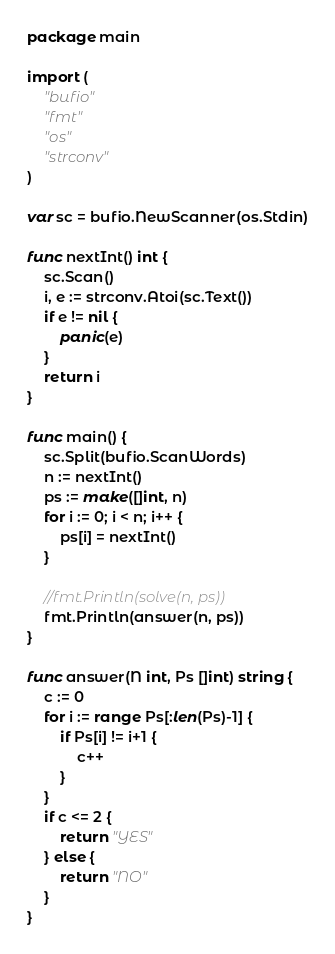<code> <loc_0><loc_0><loc_500><loc_500><_Go_>package main

import (
	"bufio"
	"fmt"
	"os"
	"strconv"
)

var sc = bufio.NewScanner(os.Stdin)

func nextInt() int {
	sc.Scan()
	i, e := strconv.Atoi(sc.Text())
	if e != nil {
		panic(e)
	}
	return i
}

func main() {
	sc.Split(bufio.ScanWords)
	n := nextInt()
	ps := make([]int, n)
	for i := 0; i < n; i++ {
		ps[i] = nextInt()
	}

	//fmt.Println(solve(n, ps))
	fmt.Println(answer(n, ps))
}

func answer(N int, Ps []int) string {
	c := 0
	for i := range Ps[:len(Ps)-1] {
		if Ps[i] != i+1 {
			c++
		}
	}
	if c <= 2 {
		return "YES"
	} else {
		return "NO"
	}
}</code> 